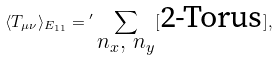Convert formula to latex. <formula><loc_0><loc_0><loc_500><loc_500>\langle T _ { \mu \nu } \rangle _ { E _ { 1 1 } } = { ^ { \prime } } \sum _ { \substack { n _ { x } , \ n _ { y } } } [ \text {2-Torus} ] ,</formula> 